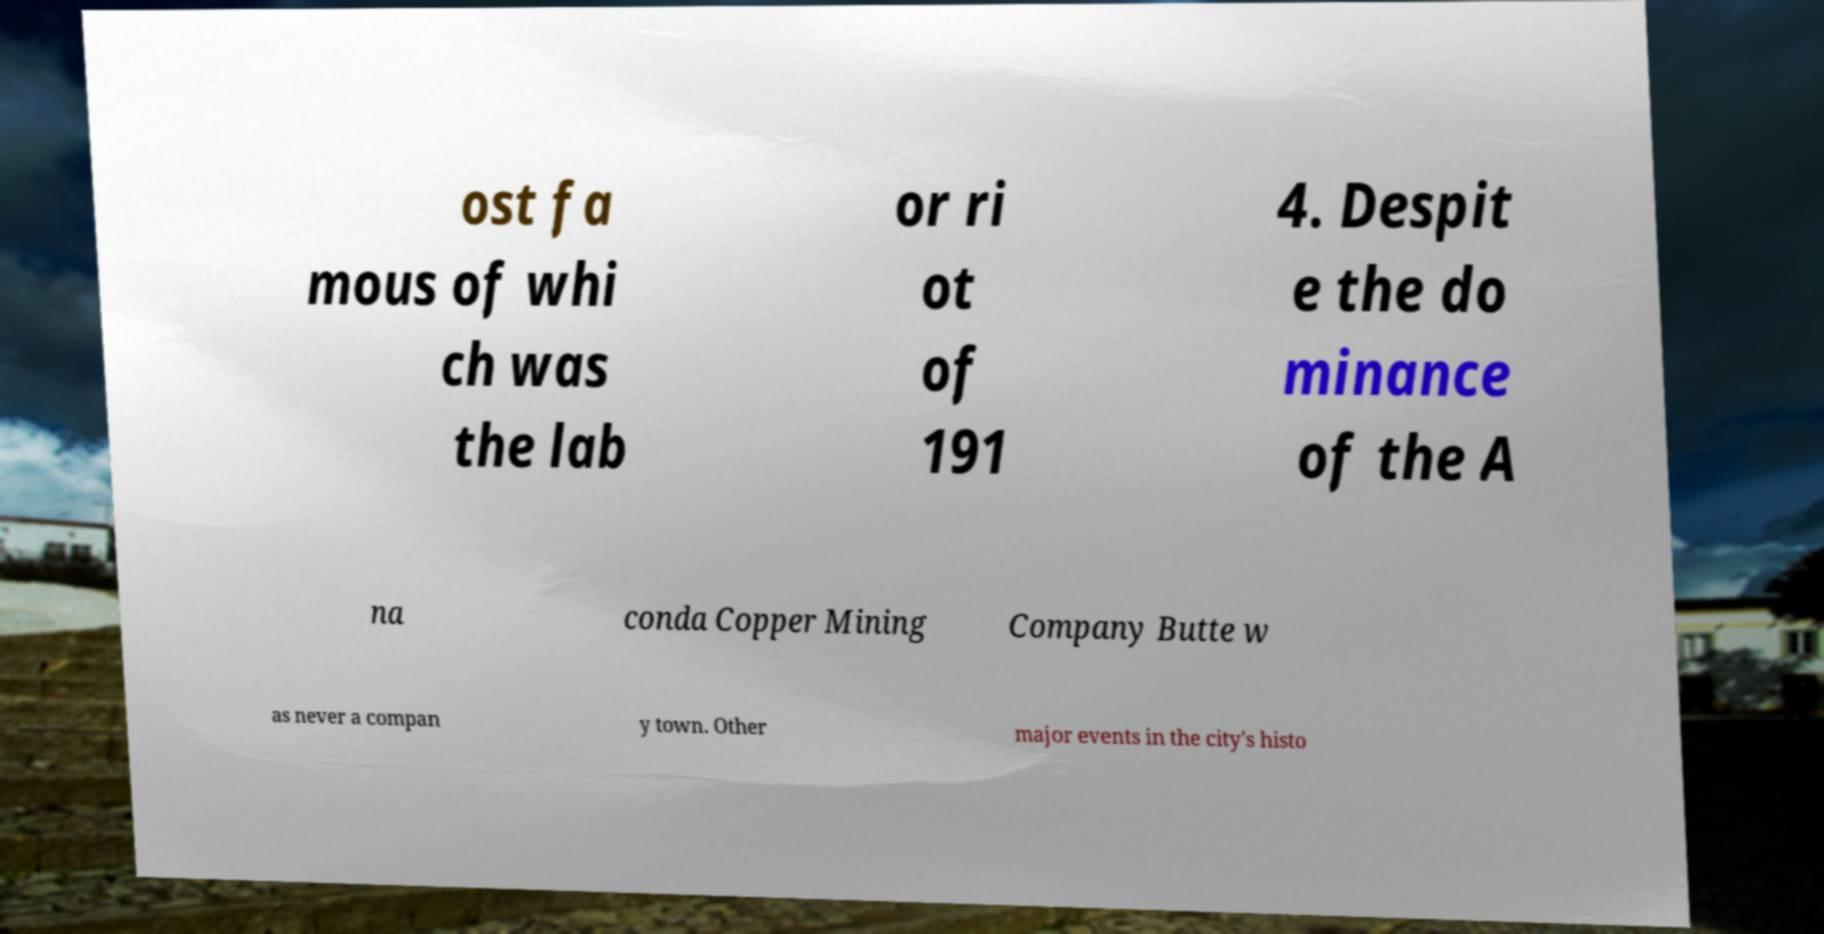Please identify and transcribe the text found in this image. ost fa mous of whi ch was the lab or ri ot of 191 4. Despit e the do minance of the A na conda Copper Mining Company Butte w as never a compan y town. Other major events in the city's histo 